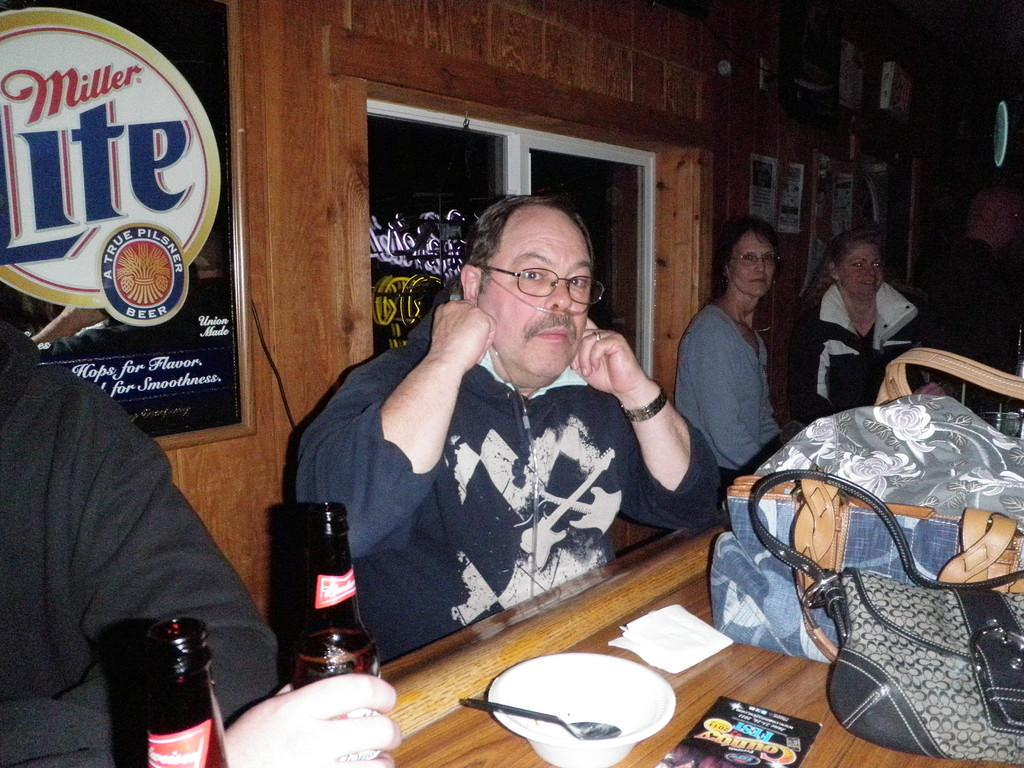What are the persons in the image doing? The persons in the image are sitting on a bench. What is located in front of the persons? There is a table in front of the persons. What can be seen on the table? There are objects on the table. How long does it take for the beggar to walk past the persons in the image? There is no beggar present in the image, so it is not possible to determine how long it would take for them to walk past the persons. 